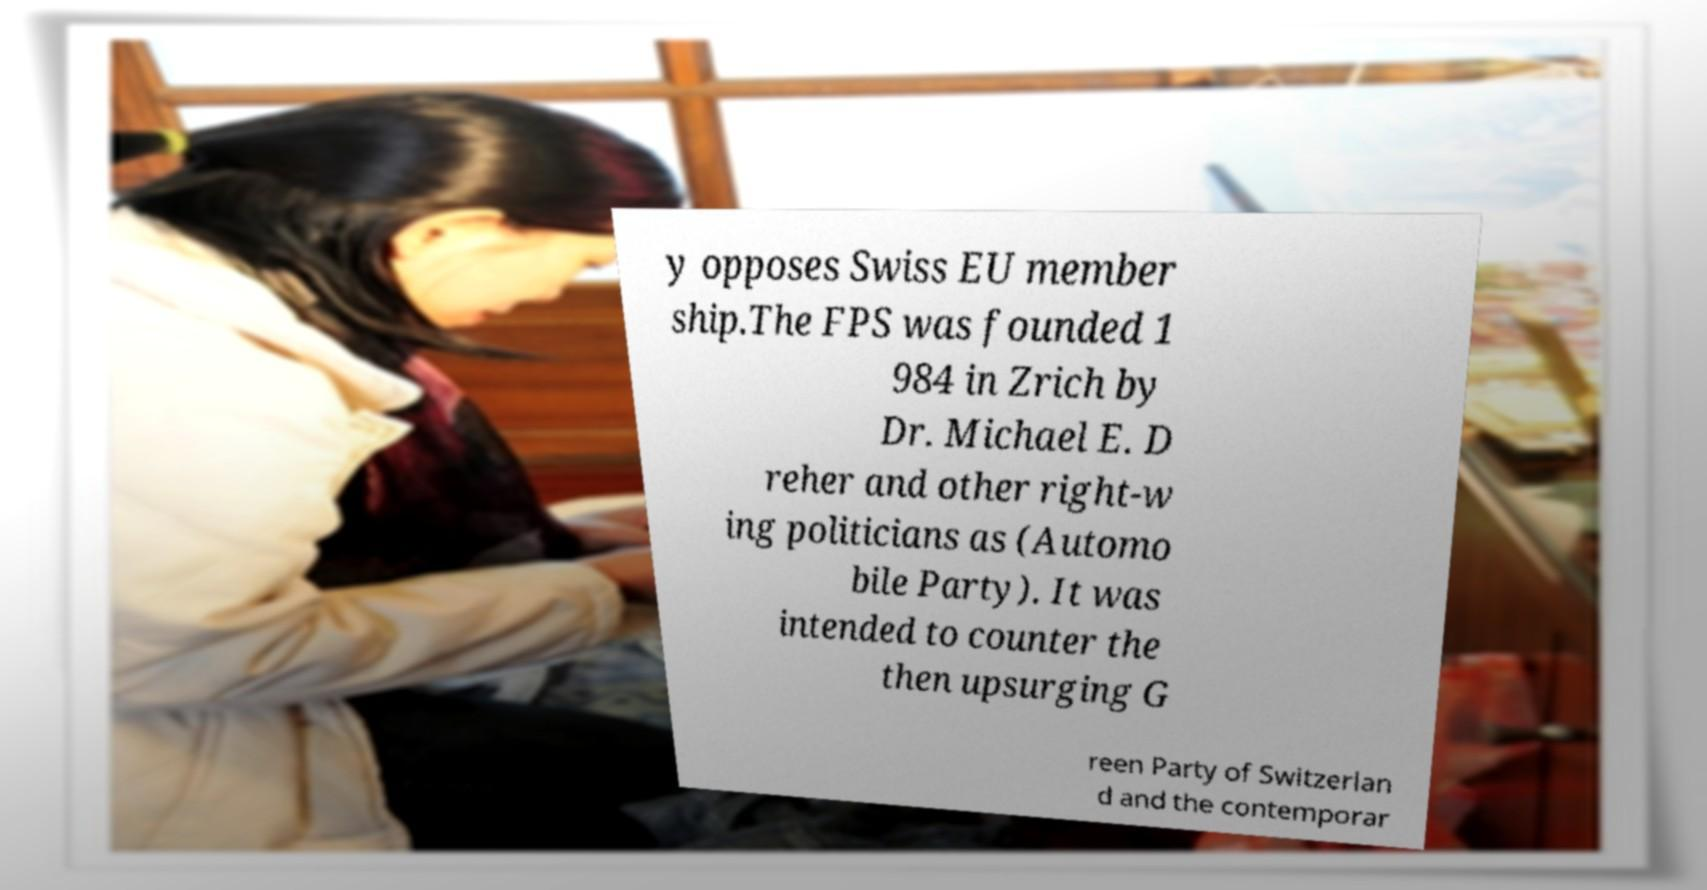Could you extract and type out the text from this image? y opposes Swiss EU member ship.The FPS was founded 1 984 in Zrich by Dr. Michael E. D reher and other right-w ing politicians as (Automo bile Party). It was intended to counter the then upsurging G reen Party of Switzerlan d and the contemporar 